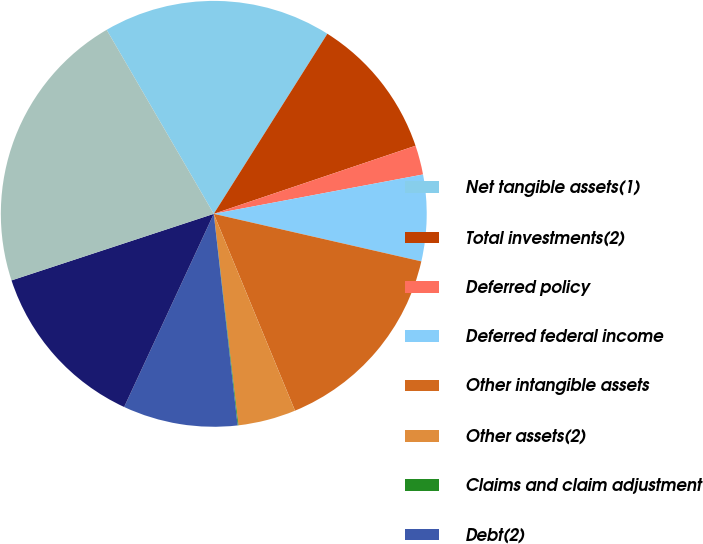Convert chart to OTSL. <chart><loc_0><loc_0><loc_500><loc_500><pie_chart><fcel>Net tangible assets(1)<fcel>Total investments(2)<fcel>Deferred policy<fcel>Deferred federal income<fcel>Other intangible assets<fcel>Other assets(2)<fcel>Claims and claim adjustment<fcel>Debt(2)<fcel>Other liabilities(2)<fcel>Allocated purchase price<nl><fcel>17.34%<fcel>10.86%<fcel>2.22%<fcel>6.54%<fcel>15.18%<fcel>4.38%<fcel>0.06%<fcel>8.7%<fcel>13.02%<fcel>21.66%<nl></chart> 